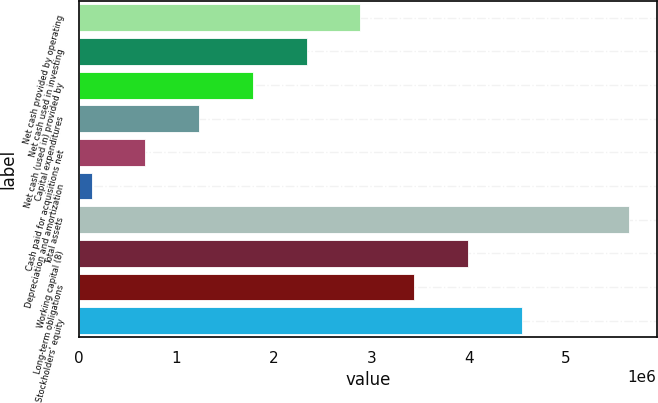Convert chart. <chart><loc_0><loc_0><loc_500><loc_500><bar_chart><fcel>Net cash provided by operating<fcel>Net cash used in investing<fcel>Net cash (used in) provided by<fcel>Capital expenditures<fcel>Cash paid for acquisitions net<fcel>Depreciation and amortization<fcel>Total assets<fcel>Working capital (8)<fcel>Long-term obligations<fcel>Stockholders' equity<nl><fcel>2.88801e+06<fcel>2.33605e+06<fcel>1.78409e+06<fcel>1.23212e+06<fcel>680156<fcel>128192<fcel>5.64784e+06<fcel>3.99194e+06<fcel>3.43998e+06<fcel>4.54391e+06<nl></chart> 